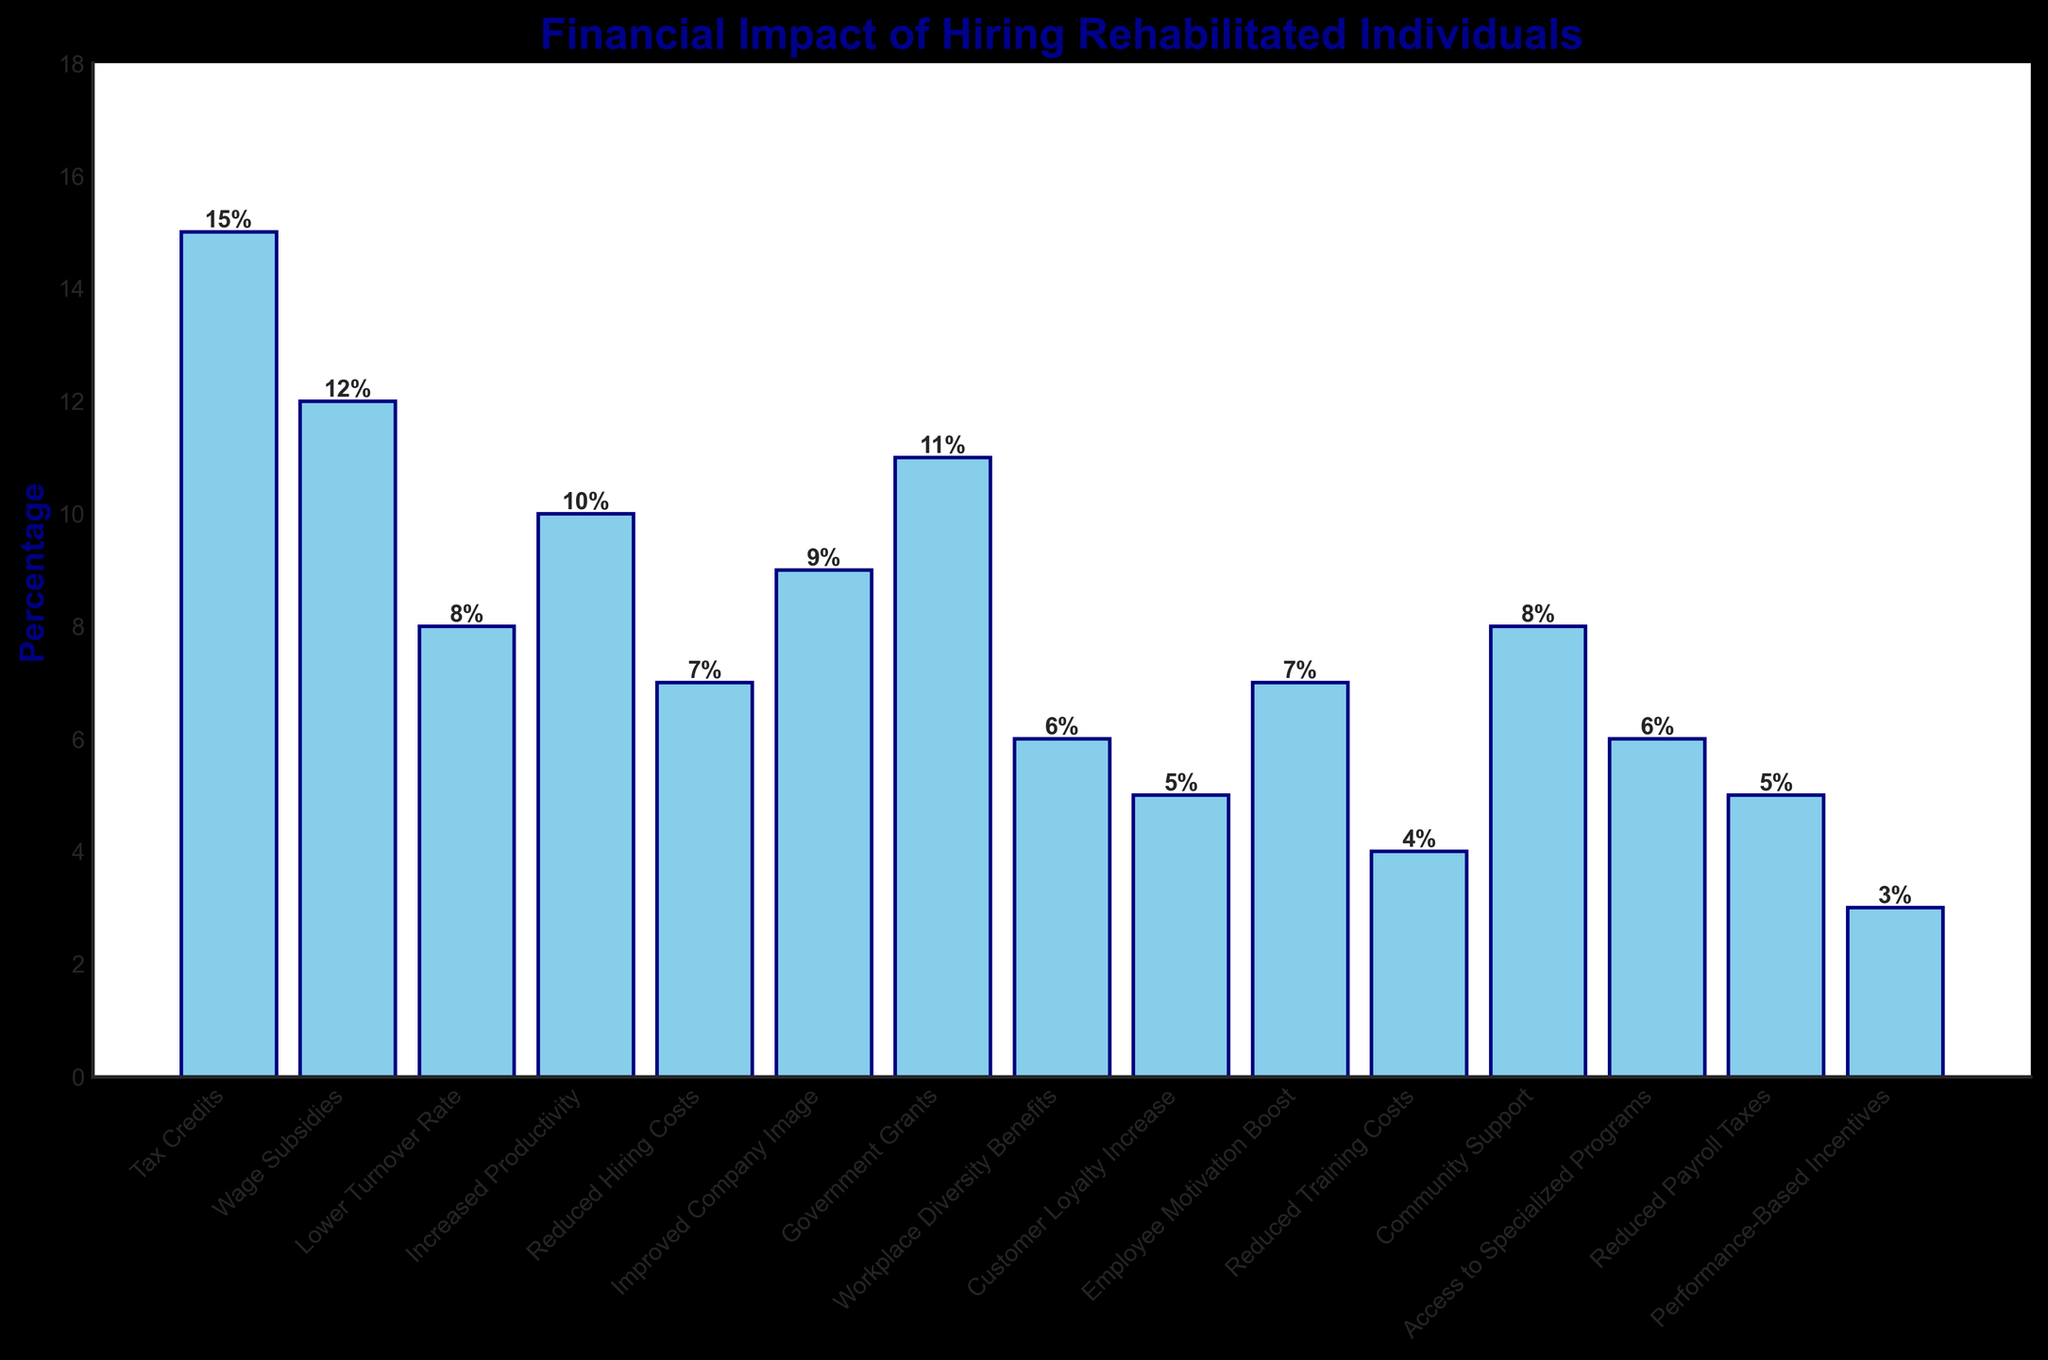Which category has the highest percentage in the financial impact? Look at the bar with the greatest height, which corresponds to "Tax Credits" at 15%.
Answer: Tax Credits How many categories have a percentage greater than 10? Identify and count the bars with a height above 10%. These categories are "Tax Credits" (15%), "Wage Subsidies" (12%), and "Government Grants" (11%).
Answer: 3 What is the total percentage for categories associated with subsidies and grants? Sum the percentages of "Wage Subsidies" (12%) and "Government Grants" (11%).
Answer: 23% Which category has the lowest percentage? Look at the bar with the smallest height, which corresponds to "Performance-Based Incentives" at 3%.
Answer: Performance-Based Incentives What is the difference in percentage between the highest and lowest categories? Subtract the percentage of the lowest category ("Performance-Based Incentives" at 3%) from the highest category ("Tax Credits" at 15%).
Answer: 12% Is the percentage for increased productivity higher or lower than for improved company image? Compare the heights of the bars for "Increased Productivity" (10%) and "Improved Company Image" (9%). "Increased Productivity" is higher.
Answer: Higher What is the combined percentage of categories related to cost reduction? Sum the percentages of "Reduced Hiring Costs" (7%), "Reduced Training Costs" (4%), and "Reduced Payroll Taxes" (5%).
Answer: 16% How does the percentage for community support compare to customer loyalty increase? Compare the heights of the bars for "Community Support" (8%) and "Customer Loyalty Increase" (5%). "Community Support" is higher.
Answer: Higher Which two categories have percentages that add up to 15%? Identify pairs of categories whose percentage summation is 15%. One such pair is "Reduced Hiring Costs" (7%) and "Workplace Diversity Benefits" (6%) which together add up to 15% (7% + 6% = 13%). This needs verification against other plausible pairs.
Answer: Reduced Hiring Costs and Employee Motivation Boost What's the average percentage across all listed categories? Sum all category percentages and divide by the number of categories: (15 + 12 + 8 + 10 + 7 + 9 + 11 + 6 + 5 + 7 + 4 + 8 + 6 + 5 + 3) / 15 = 116 / 15 = 7.73
Answer: 7.73% 